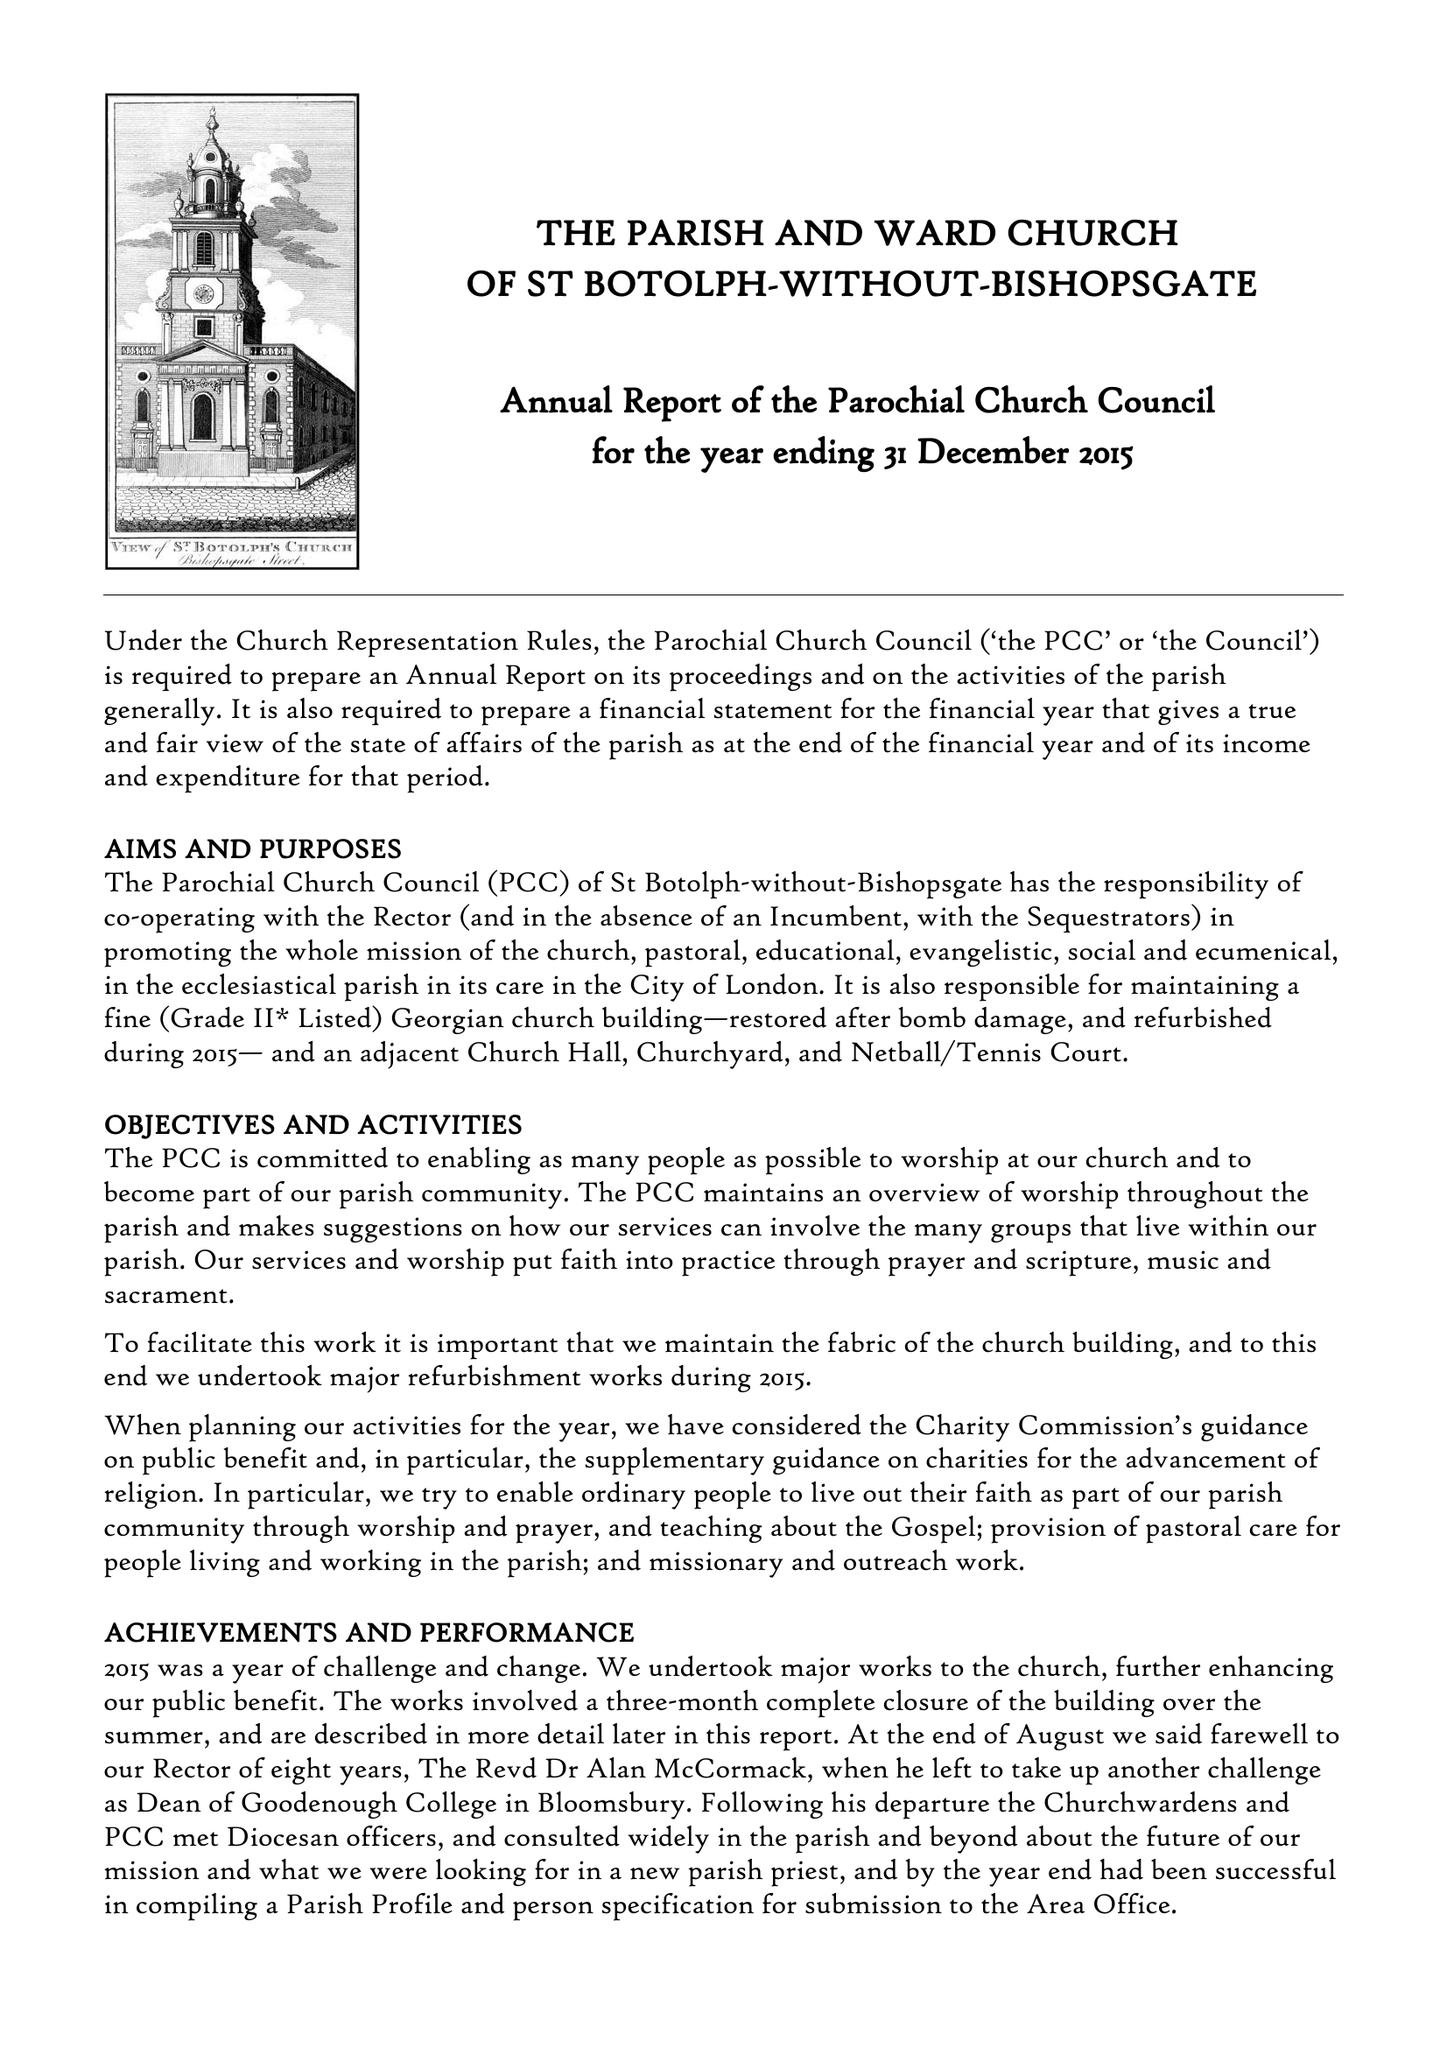What is the value for the income_annually_in_british_pounds?
Answer the question using a single word or phrase. 232387.00 